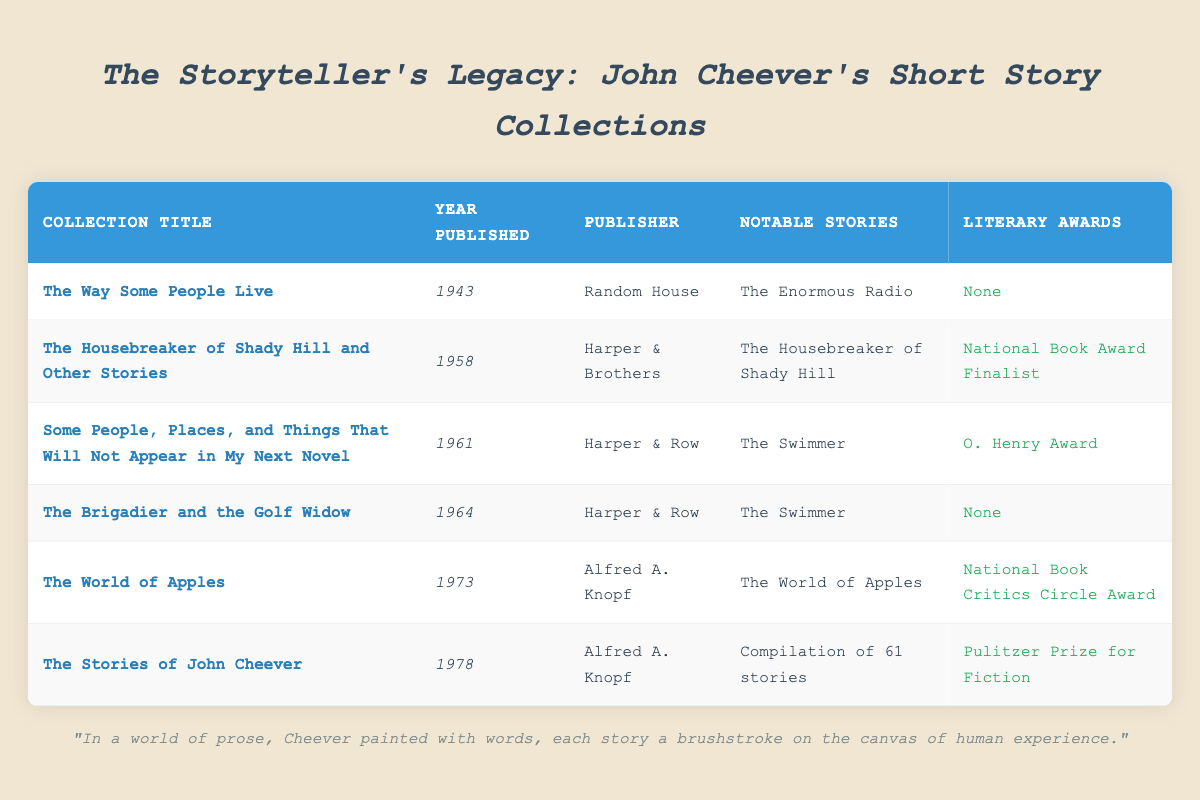What year was "The Housebreaker of Shady Hill and Other Stories" published? The table shows a specific column for years published. Looking under the "Collection Title" column, I locate "The Housebreaker of Shady Hill and Other Stories," which corresponds to the year 1958 in the same row.
Answer: 1958 Which collection was published by Harper & Row? In the "Publisher" column, I search for "Harper & Row." Upon inspection, I see that two collections—"Some People, Places, and Things That Will Not Appear in My Next Novel" and "The Brigadier and the Golf Widow"—list this publisher.
Answer: Some People, Places, and Things That Will Not Appear in My Next Novel, The Brigadier and the Golf Widow Did "The World of Apples" win any literary awards? I look at the "Literary Awards" column next to "The World of Apples" and see that it won the National Book Critics Circle Award, which means the answer to this question is yes.
Answer: Yes What are the notable stories in "The Stories of John Cheever"? By checking the "Notable Stories" column for "The Stories of John Cheever," I see it lists "Compilation of 61 stories." This indicates that it does not focus on a single notable story, but rather a collection.
Answer: Compilation of 61 stories How many collections were published before 1970? I examine the "Year Published" column and note the years of each collection: 1943, 1958, 1961, 1964, and 1973. Collectively, the collections from 1943 to 1964 (5 total) are before 1970.
Answer: 5 Which collection had the most notable stories listed? Referring to the "Notable Stories" column, I make comparisons. The "Stories of John Cheever" mentions a compilation of 61 stories, more than any other. Thus, it stands out regarding notable stories.
Answer: The Stories of John Cheever Who published "The Way Some People Live"? I locate "The Way Some People Live" under the "Collection Title" column and check the corresponding "Publisher" column, which indicates Random House was the publisher.
Answer: Random House Is "The Housebreaker of Shady Hill and Other Stories" a finalist for any literary awards? I find "The Housebreaker of Shady Hill and Other Stories" in the table; the corresponding cell in the "Literary Awards" column indicates it was a National Book Award Finalist, meaning the answer to the question is yes.
Answer: Yes What is the range of years in which the collections were published? I check the years in the "Year Published" column, noting the collection published in 1943 and the one from 1978. The range is calculated by subtracting the earliest year (1943) from the latest year (1978), giving a total of 35 years.
Answer: 35 years 